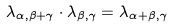<formula> <loc_0><loc_0><loc_500><loc_500>\lambda _ { \alpha , \beta + \gamma } \cdot \lambda _ { \beta , \gamma } = \lambda _ { \alpha + \beta , \gamma }</formula> 